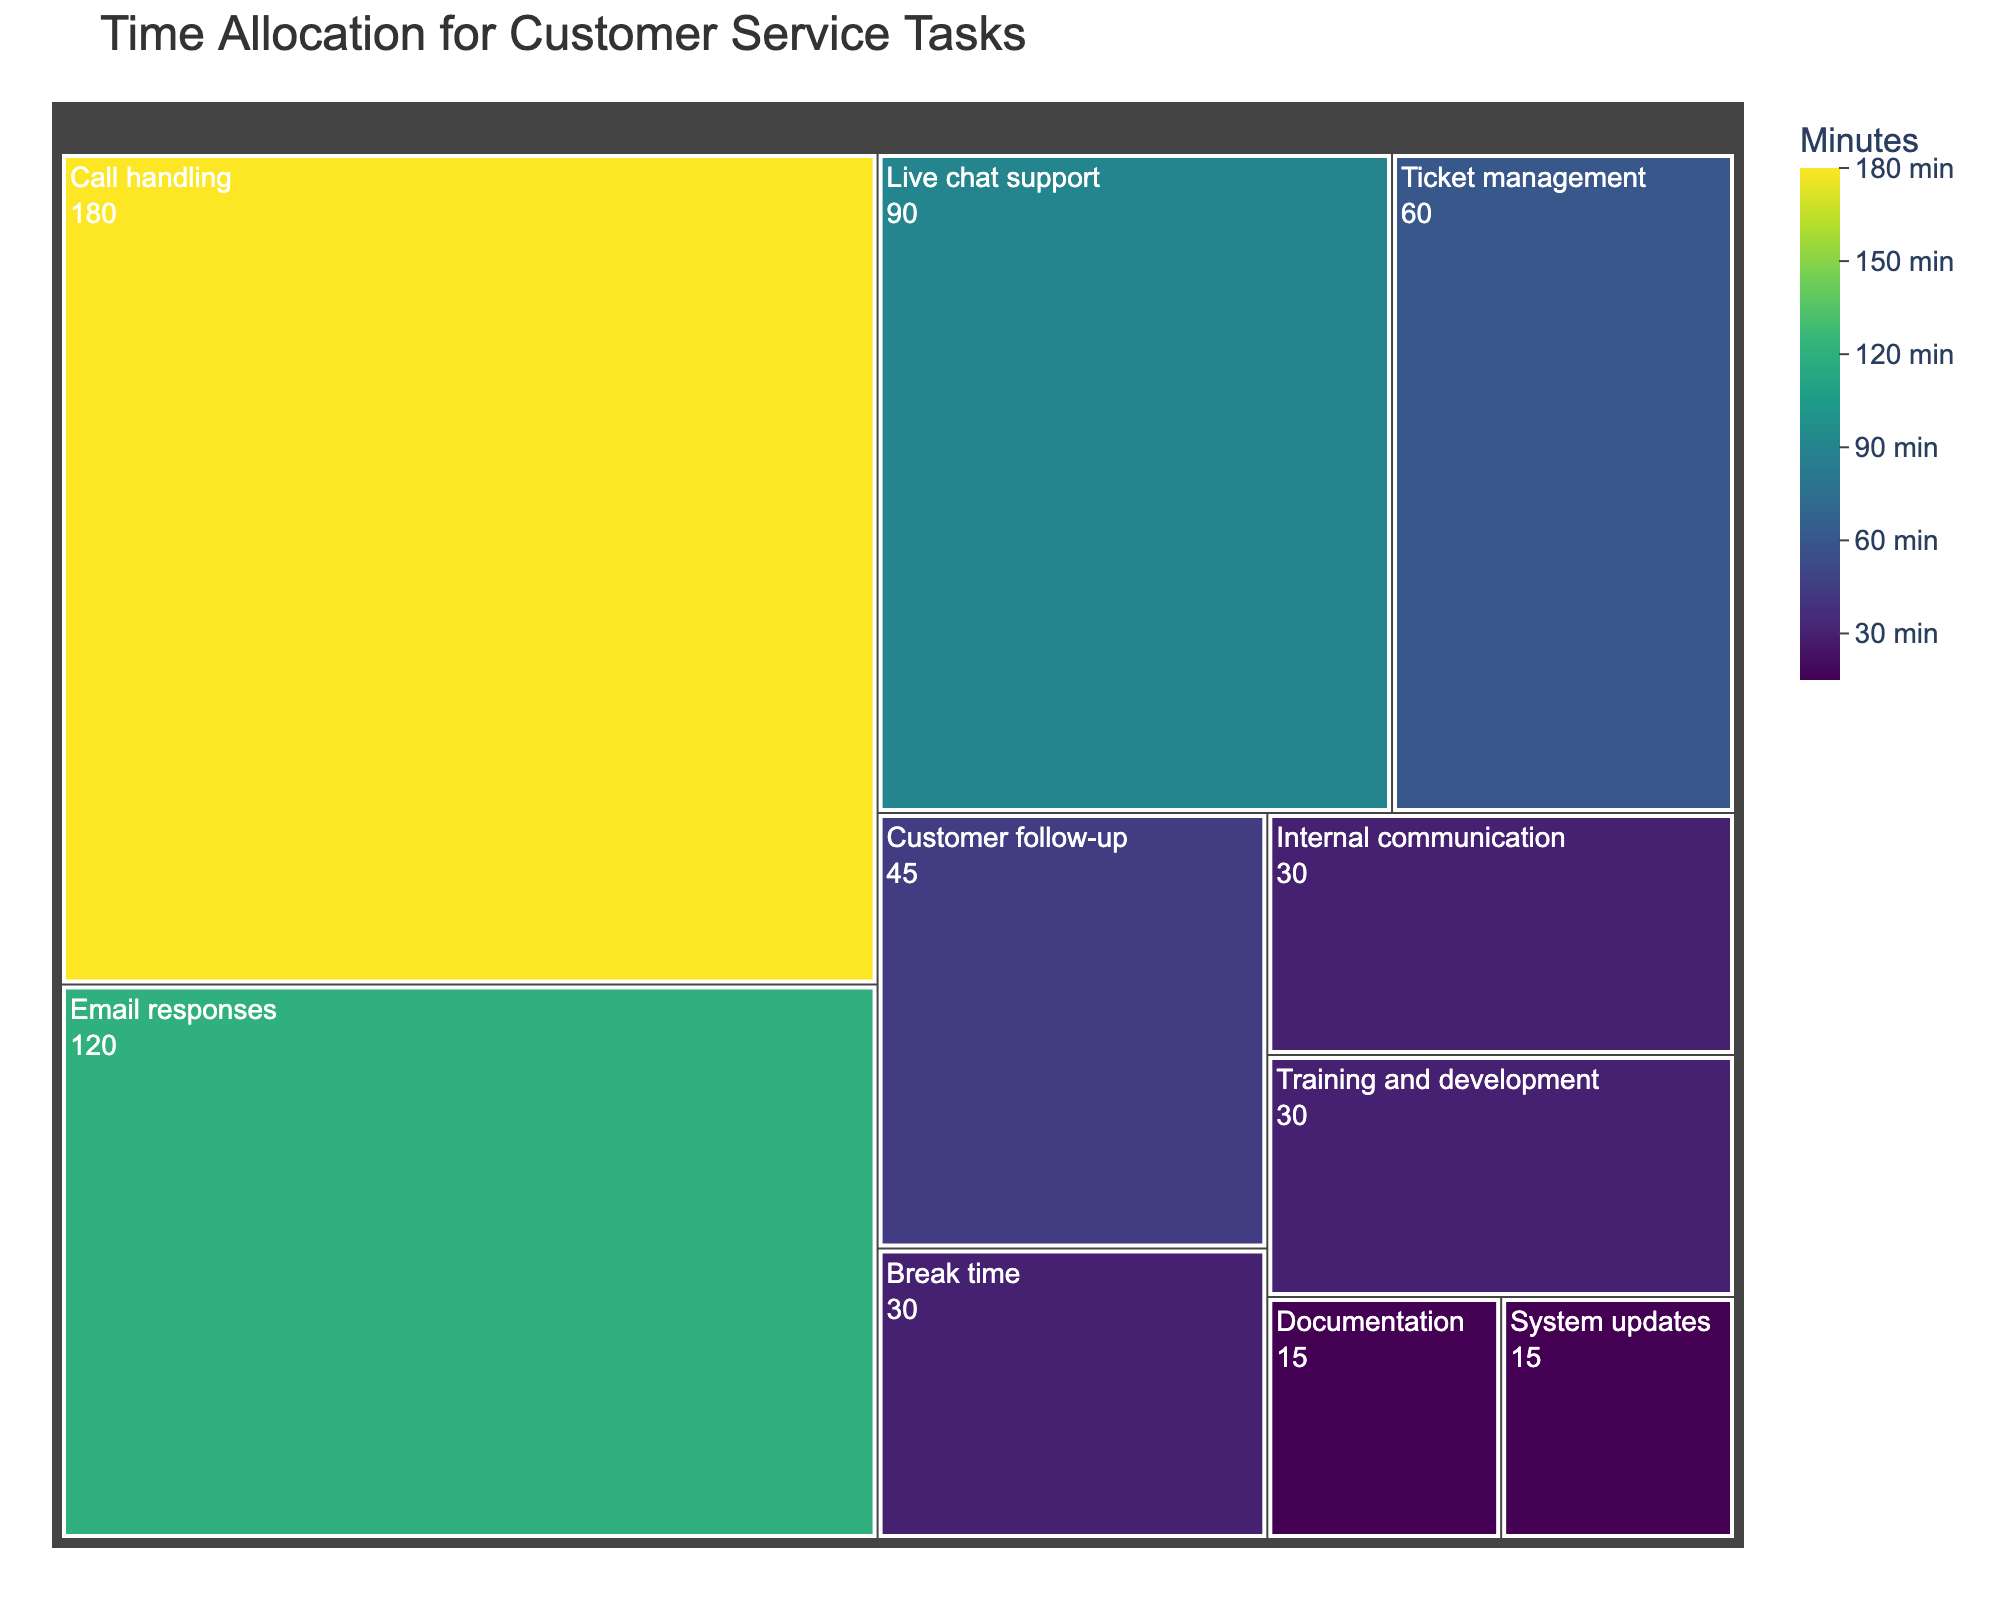Which task takes the most time in the typical workday? The figure shows the time allocation for various customer service tasks in minutes. The task with the largest section should be identified.
Answer: Call handling Which tasks take less than 30 minutes each? Look for sections in the treemap with values under 30 minutes.
Answer: System updates, Documentation What is the total time spent on tasks related to customer communication (Call handling, Email responses, Live chat support, and Customer follow-up)? Identify the sections related to customer communication and sum their time values. Call handling (180) + Email responses (120) + Live chat support (90) + Customer follow-up (45) = 435 minutes.
Answer: 435 minutes How much more time is spent on Call handling compared to Email responses? Subtract the time allocated to Email responses from the time allocated to Call handling. 180 - 120 = 60 minutes.
Answer: 60 minutes Which task takes the least amount of time, and how much time is spent on it? Identify the smallest section in the treemap and note its label and value.
Answer: System updates, 15 minutes How does the time spent on Break time compare to the time spent on Internal communication? Identify the time allocated to Break time and Internal communication and compare the values. Both are 30 minutes, so they are equal.
Answer: It is equal What percentage of the workday is spent on Training and development? Use the given data to find the total time (sum all the times). Then, divide the time for Training and development by this total and multiply by 100 for the percentage. Total = 180 + 120 + 90 + 60 + 45 + 30 + 30 + 30 + 15 + 15 = 615 minutes. So, (30 / 615) * 100 ≈ 4.88%.
Answer: Approximately 4.88% What is the average time spent per task? Sum all the time values and divide by the number of tasks. Total time is 615 minutes, with 10 tasks. So, 615 / 10 = 61.5 minutes per task.
Answer: 61.5 minutes Rank the tasks from the highest to the lowest time allocation. List the tasks in descending order based on their time values.
Answer: Call handling, Email responses, Live chat support, Ticket management, Customer follow-up, Break time, Internal communication, Training and development, System updates, Documentation 